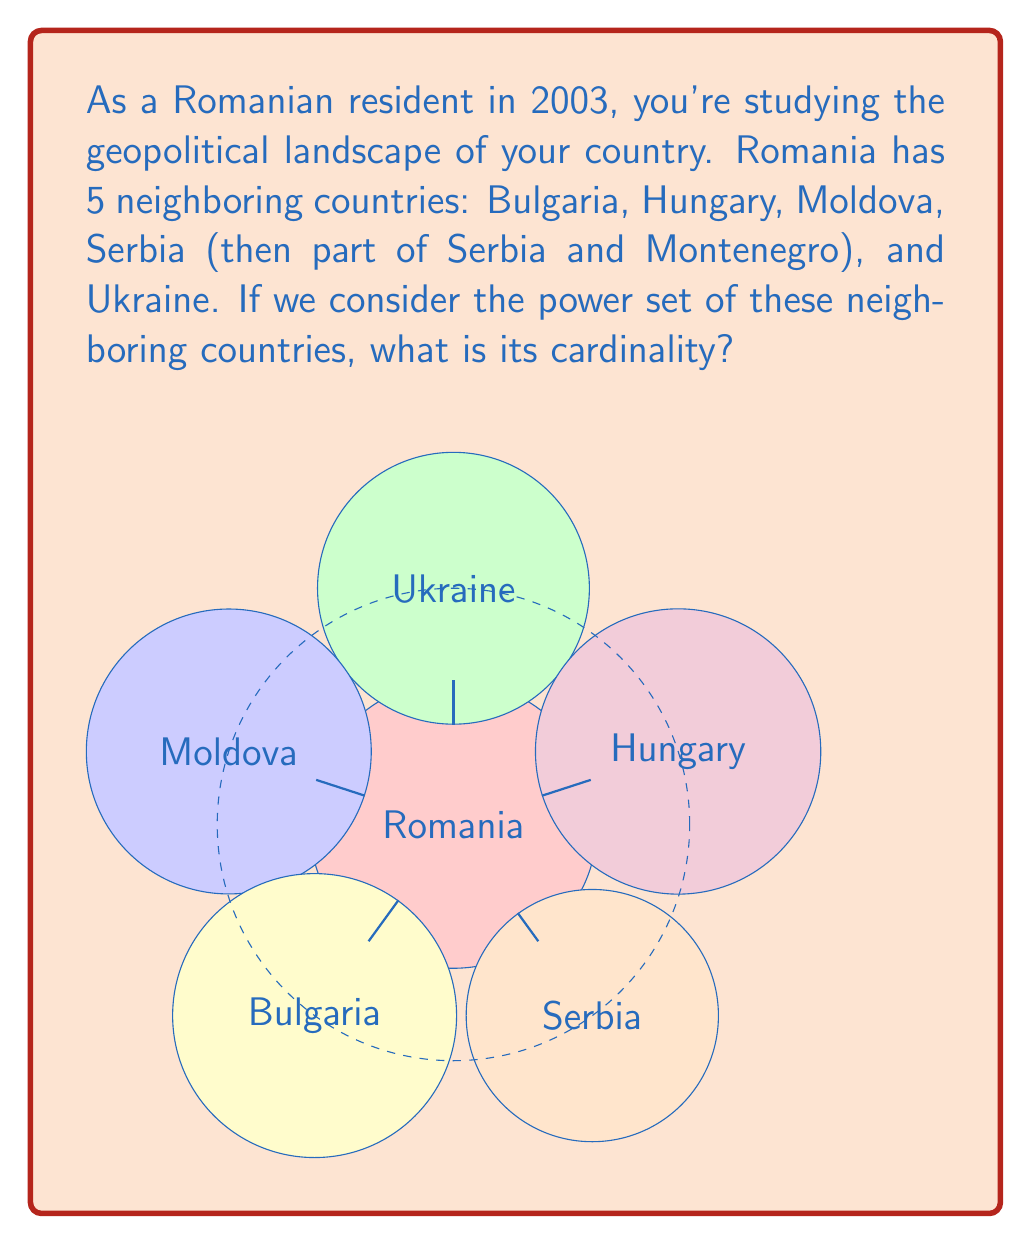Provide a solution to this math problem. To solve this problem, let's follow these steps:

1) First, recall that the power set of a set $A$ is the set of all subsets of $A$, including the empty set and $A$ itself.

2) Let's define our set of neighboring countries:
   $N = \{\text{Bulgaria, Hungary, Moldova, Serbia, Ukraine}\}$

3) The number of elements in set $N$ is 5.

4) For a set with $n$ elements, the cardinality of its power set is given by the formula:

   $|P(N)| = 2^n$

   Where $|P(N)|$ represents the cardinality of the power set of $N$.

5) In this case, $n = 5$, so we have:

   $|P(N)| = 2^5$

6) Calculate $2^5$:
   $2^5 = 2 \times 2 \times 2 \times 2 \times 2 = 32$

Therefore, the cardinality of the power set of Romania's neighboring countries is 32.
Answer: $32$ 